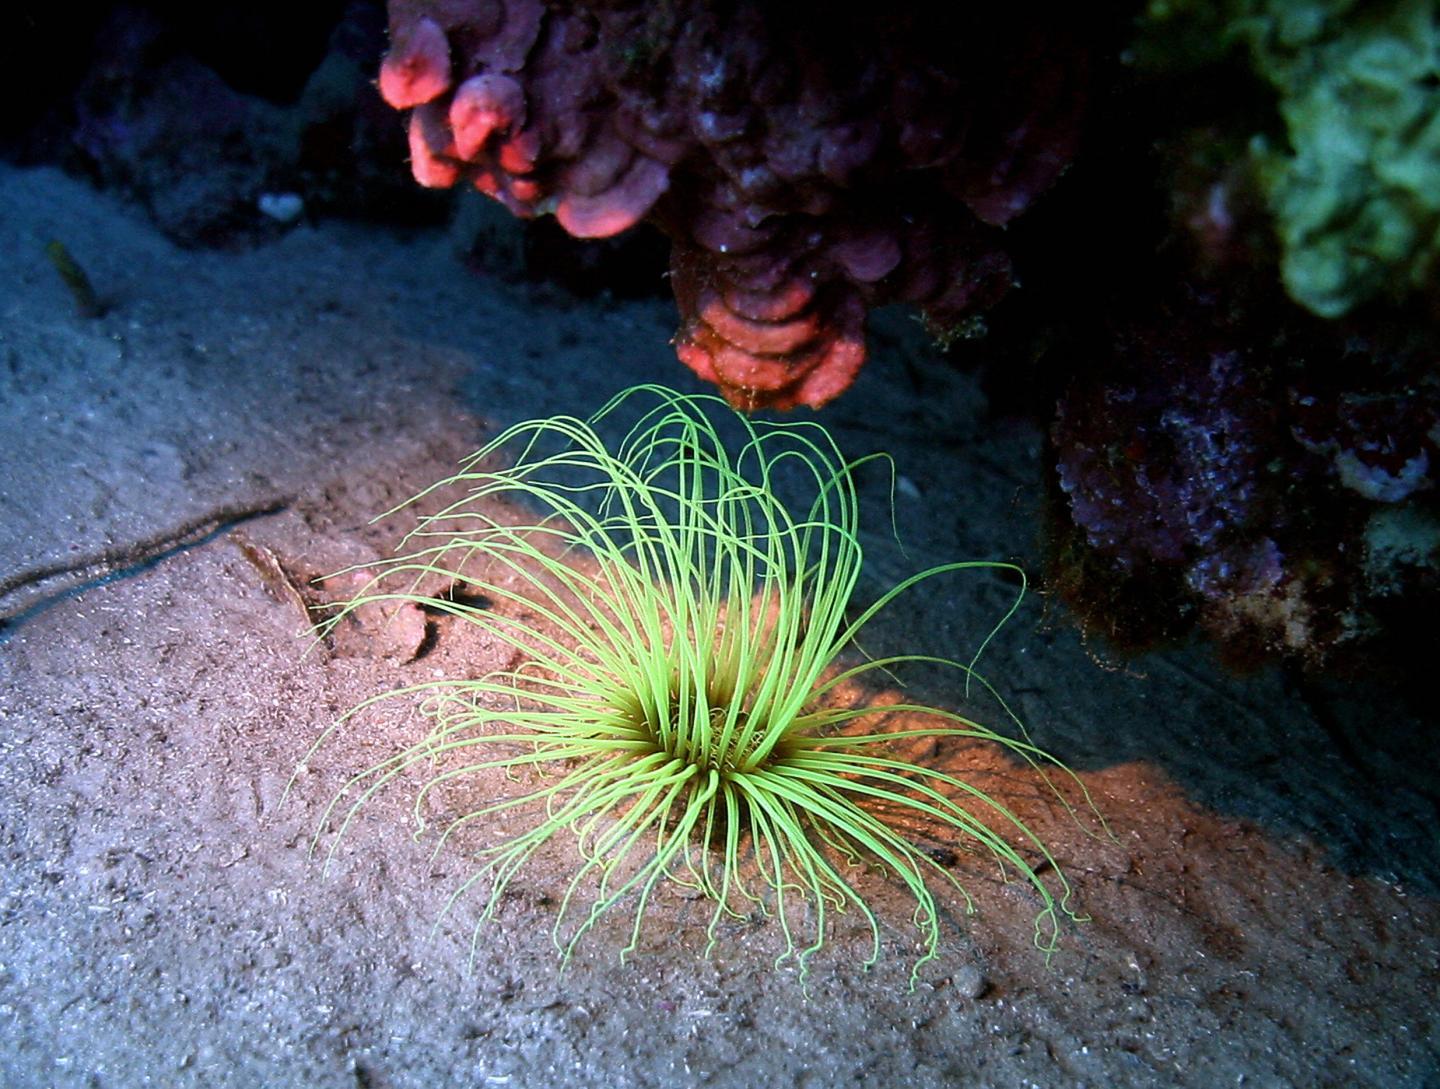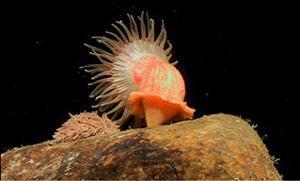The first image is the image on the left, the second image is the image on the right. Considering the images on both sides, is "The anemone in the left image is orange." valid? Answer yes or no. No. The first image is the image on the left, the second image is the image on the right. Examine the images to the left and right. Is the description "In one image in each pair there is a starfish to the left of an anenome." accurate? Answer yes or no. No. 